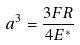Convert formula to latex. <formula><loc_0><loc_0><loc_500><loc_500>a ^ { 3 } = \frac { 3 F R } { 4 E ^ { * } }</formula> 